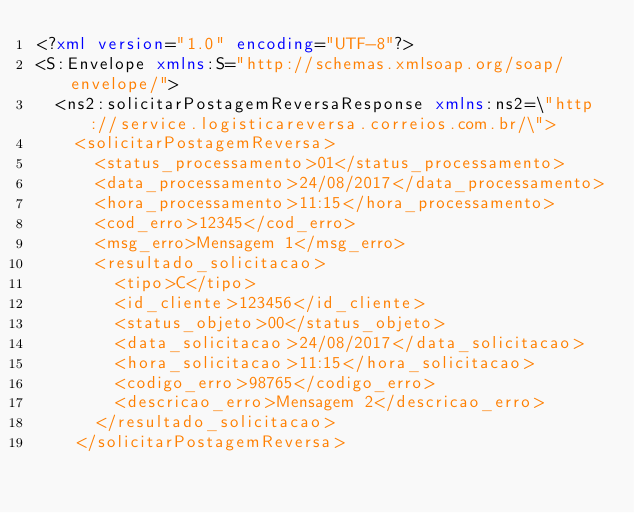<code> <loc_0><loc_0><loc_500><loc_500><_XML_><?xml version="1.0" encoding="UTF-8"?>
<S:Envelope xmlns:S="http://schemas.xmlsoap.org/soap/envelope/">
  <ns2:solicitarPostagemReversaResponse xmlns:ns2=\"http://service.logisticareversa.correios.com.br/\">
    <solicitarPostagemReversa>
      <status_processamento>01</status_processamento>
      <data_processamento>24/08/2017</data_processamento>
      <hora_processamento>11:15</hora_processamento>
      <cod_erro>12345</cod_erro>
      <msg_erro>Mensagem 1</msg_erro>
      <resultado_solicitacao>
        <tipo>C</tipo>
        <id_cliente>123456</id_cliente>
        <status_objeto>00</status_objeto>
        <data_solicitacao>24/08/2017</data_solicitacao>
        <hora_solicitacao>11:15</hora_solicitacao>
        <codigo_erro>98765</codigo_erro>
        <descricao_erro>Mensagem 2</descricao_erro>
      </resultado_solicitacao>
    </solicitarPostagemReversa></code> 